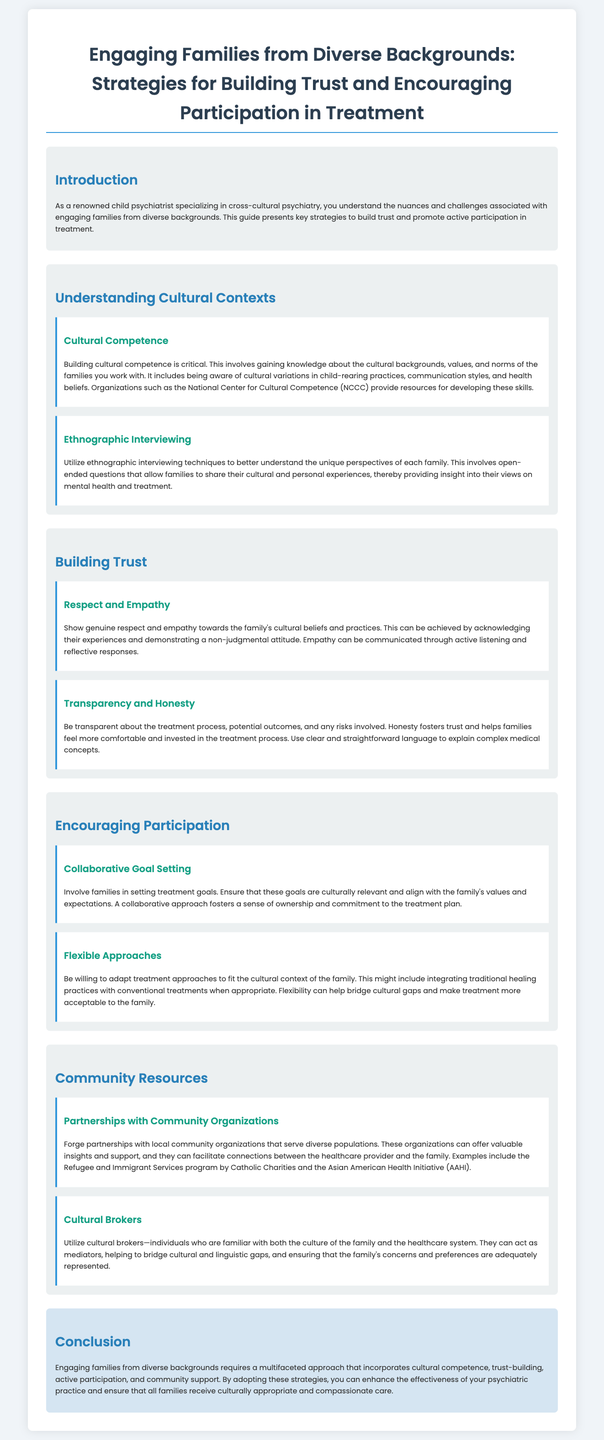what is the title of the document? The title is presented prominently at the top of the document, summarizing its focus on family engagement and cultural diversity.
Answer: Engaging Families from Diverse Backgrounds: Strategies for Building Trust and Encouraging Participation in Treatment what organization provides resources for developing cultural competence? The document mentions the National Center for Cultural Competence as a resource for building cultural competence.
Answer: National Center for Cultural Competence (NCCC) what is one technique mentioned for understanding families' perspectives? Ethnographic interviewing is cited as a technique used to gain insights into families' views on mental health.
Answer: Ethnographic interviewing name one strategy for building trust with families? The document lists respect and empathy as critical components for building trust with families.
Answer: Respect and empathy how should treatment goals be set according to the document? The document emphasizes involving families in setting treatment goals that align with their values and expectations.
Answer: Collaborative goal setting what role do cultural brokers play? Cultural brokers help bridge cultural and linguistic gaps between families and the healthcare system, ensuring effective communication.
Answer: Mediators what does the conclusion emphasize about engaging families from diverse backgrounds? The conclusion highlights the need for a multifaceted approach that includes cultural competence, trust-building, and community support.
Answer: Multifaceted approach what agency is mentioned as a partner for community resources? The document provides an example of Catholic Charities as a community organization that can help engage diverse populations.
Answer: Catholic Charities 